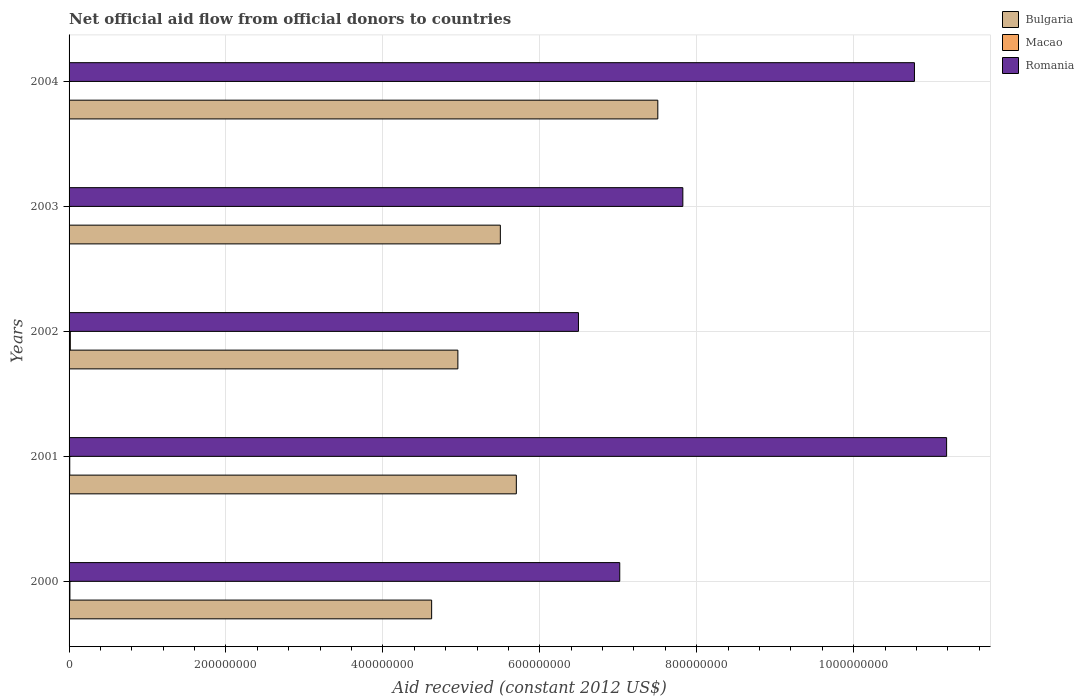How many different coloured bars are there?
Keep it short and to the point. 3. Are the number of bars per tick equal to the number of legend labels?
Keep it short and to the point. Yes. How many bars are there on the 4th tick from the top?
Offer a very short reply. 3. How many bars are there on the 3rd tick from the bottom?
Ensure brevity in your answer.  3. What is the label of the 3rd group of bars from the top?
Your answer should be very brief. 2002. What is the total aid received in Bulgaria in 2001?
Your answer should be compact. 5.70e+08. Across all years, what is the maximum total aid received in Romania?
Offer a terse response. 1.12e+09. Across all years, what is the minimum total aid received in Macao?
Provide a short and direct response. 1.50e+05. In which year was the total aid received in Romania maximum?
Your answer should be very brief. 2001. In which year was the total aid received in Romania minimum?
Your answer should be very brief. 2002. What is the total total aid received in Bulgaria in the graph?
Ensure brevity in your answer.  2.83e+09. What is the difference between the total aid received in Bulgaria in 2000 and that in 2004?
Give a very brief answer. -2.88e+08. What is the difference between the total aid received in Macao in 2003 and the total aid received in Romania in 2002?
Your answer should be compact. -6.49e+08. What is the average total aid received in Romania per year?
Your response must be concise. 8.66e+08. In the year 2002, what is the difference between the total aid received in Romania and total aid received in Macao?
Your response must be concise. 6.48e+08. In how many years, is the total aid received in Romania greater than 1040000000 US$?
Your answer should be very brief. 2. What is the ratio of the total aid received in Romania in 2002 to that in 2004?
Offer a very short reply. 0.6. What is the difference between the highest and the lowest total aid received in Macao?
Your answer should be compact. 1.43e+06. In how many years, is the total aid received in Macao greater than the average total aid received in Macao taken over all years?
Keep it short and to the point. 3. What does the 2nd bar from the top in 2003 represents?
Your answer should be compact. Macao. What does the 3rd bar from the bottom in 2004 represents?
Your response must be concise. Romania. Is it the case that in every year, the sum of the total aid received in Romania and total aid received in Bulgaria is greater than the total aid received in Macao?
Keep it short and to the point. Yes. Does the graph contain grids?
Your answer should be compact. Yes. How are the legend labels stacked?
Your answer should be compact. Vertical. What is the title of the graph?
Your answer should be very brief. Net official aid flow from official donors to countries. Does "Kenya" appear as one of the legend labels in the graph?
Provide a short and direct response. No. What is the label or title of the X-axis?
Your answer should be very brief. Aid recevied (constant 2012 US$). What is the Aid recevied (constant 2012 US$) of Bulgaria in 2000?
Make the answer very short. 4.62e+08. What is the Aid recevied (constant 2012 US$) of Macao in 2000?
Offer a terse response. 1.08e+06. What is the Aid recevied (constant 2012 US$) of Romania in 2000?
Make the answer very short. 7.02e+08. What is the Aid recevied (constant 2012 US$) in Bulgaria in 2001?
Keep it short and to the point. 5.70e+08. What is the Aid recevied (constant 2012 US$) of Macao in 2001?
Make the answer very short. 8.60e+05. What is the Aid recevied (constant 2012 US$) in Romania in 2001?
Offer a very short reply. 1.12e+09. What is the Aid recevied (constant 2012 US$) of Bulgaria in 2002?
Offer a terse response. 4.96e+08. What is the Aid recevied (constant 2012 US$) in Macao in 2002?
Your answer should be compact. 1.58e+06. What is the Aid recevied (constant 2012 US$) of Romania in 2002?
Offer a very short reply. 6.49e+08. What is the Aid recevied (constant 2012 US$) of Bulgaria in 2003?
Make the answer very short. 5.50e+08. What is the Aid recevied (constant 2012 US$) of Romania in 2003?
Keep it short and to the point. 7.82e+08. What is the Aid recevied (constant 2012 US$) of Bulgaria in 2004?
Your answer should be very brief. 7.50e+08. What is the Aid recevied (constant 2012 US$) in Macao in 2004?
Provide a short and direct response. 1.50e+05. What is the Aid recevied (constant 2012 US$) of Romania in 2004?
Keep it short and to the point. 1.08e+09. Across all years, what is the maximum Aid recevied (constant 2012 US$) of Bulgaria?
Offer a terse response. 7.50e+08. Across all years, what is the maximum Aid recevied (constant 2012 US$) in Macao?
Provide a succinct answer. 1.58e+06. Across all years, what is the maximum Aid recevied (constant 2012 US$) in Romania?
Keep it short and to the point. 1.12e+09. Across all years, what is the minimum Aid recevied (constant 2012 US$) of Bulgaria?
Give a very brief answer. 4.62e+08. Across all years, what is the minimum Aid recevied (constant 2012 US$) of Romania?
Provide a succinct answer. 6.49e+08. What is the total Aid recevied (constant 2012 US$) in Bulgaria in the graph?
Give a very brief answer. 2.83e+09. What is the total Aid recevied (constant 2012 US$) in Macao in the graph?
Your answer should be compact. 3.85e+06. What is the total Aid recevied (constant 2012 US$) of Romania in the graph?
Your answer should be very brief. 4.33e+09. What is the difference between the Aid recevied (constant 2012 US$) of Bulgaria in 2000 and that in 2001?
Your answer should be compact. -1.08e+08. What is the difference between the Aid recevied (constant 2012 US$) in Romania in 2000 and that in 2001?
Your answer should be compact. -4.17e+08. What is the difference between the Aid recevied (constant 2012 US$) in Bulgaria in 2000 and that in 2002?
Provide a short and direct response. -3.34e+07. What is the difference between the Aid recevied (constant 2012 US$) in Macao in 2000 and that in 2002?
Offer a terse response. -5.00e+05. What is the difference between the Aid recevied (constant 2012 US$) of Romania in 2000 and that in 2002?
Make the answer very short. 5.26e+07. What is the difference between the Aid recevied (constant 2012 US$) in Bulgaria in 2000 and that in 2003?
Keep it short and to the point. -8.76e+07. What is the difference between the Aid recevied (constant 2012 US$) in Macao in 2000 and that in 2003?
Offer a very short reply. 9.00e+05. What is the difference between the Aid recevied (constant 2012 US$) in Romania in 2000 and that in 2003?
Give a very brief answer. -8.04e+07. What is the difference between the Aid recevied (constant 2012 US$) in Bulgaria in 2000 and that in 2004?
Give a very brief answer. -2.88e+08. What is the difference between the Aid recevied (constant 2012 US$) in Macao in 2000 and that in 2004?
Your response must be concise. 9.30e+05. What is the difference between the Aid recevied (constant 2012 US$) of Romania in 2000 and that in 2004?
Provide a short and direct response. -3.76e+08. What is the difference between the Aid recevied (constant 2012 US$) of Bulgaria in 2001 and that in 2002?
Ensure brevity in your answer.  7.45e+07. What is the difference between the Aid recevied (constant 2012 US$) in Macao in 2001 and that in 2002?
Provide a succinct answer. -7.20e+05. What is the difference between the Aid recevied (constant 2012 US$) of Romania in 2001 and that in 2002?
Offer a terse response. 4.69e+08. What is the difference between the Aid recevied (constant 2012 US$) in Bulgaria in 2001 and that in 2003?
Offer a very short reply. 2.04e+07. What is the difference between the Aid recevied (constant 2012 US$) in Macao in 2001 and that in 2003?
Offer a terse response. 6.80e+05. What is the difference between the Aid recevied (constant 2012 US$) of Romania in 2001 and that in 2003?
Keep it short and to the point. 3.36e+08. What is the difference between the Aid recevied (constant 2012 US$) in Bulgaria in 2001 and that in 2004?
Offer a terse response. -1.80e+08. What is the difference between the Aid recevied (constant 2012 US$) in Macao in 2001 and that in 2004?
Provide a succinct answer. 7.10e+05. What is the difference between the Aid recevied (constant 2012 US$) of Romania in 2001 and that in 2004?
Provide a succinct answer. 4.10e+07. What is the difference between the Aid recevied (constant 2012 US$) of Bulgaria in 2002 and that in 2003?
Keep it short and to the point. -5.41e+07. What is the difference between the Aid recevied (constant 2012 US$) of Macao in 2002 and that in 2003?
Offer a very short reply. 1.40e+06. What is the difference between the Aid recevied (constant 2012 US$) of Romania in 2002 and that in 2003?
Provide a succinct answer. -1.33e+08. What is the difference between the Aid recevied (constant 2012 US$) in Bulgaria in 2002 and that in 2004?
Give a very brief answer. -2.55e+08. What is the difference between the Aid recevied (constant 2012 US$) in Macao in 2002 and that in 2004?
Provide a short and direct response. 1.43e+06. What is the difference between the Aid recevied (constant 2012 US$) in Romania in 2002 and that in 2004?
Make the answer very short. -4.28e+08. What is the difference between the Aid recevied (constant 2012 US$) in Bulgaria in 2003 and that in 2004?
Provide a short and direct response. -2.01e+08. What is the difference between the Aid recevied (constant 2012 US$) in Macao in 2003 and that in 2004?
Provide a short and direct response. 3.00e+04. What is the difference between the Aid recevied (constant 2012 US$) in Romania in 2003 and that in 2004?
Ensure brevity in your answer.  -2.95e+08. What is the difference between the Aid recevied (constant 2012 US$) in Bulgaria in 2000 and the Aid recevied (constant 2012 US$) in Macao in 2001?
Ensure brevity in your answer.  4.61e+08. What is the difference between the Aid recevied (constant 2012 US$) of Bulgaria in 2000 and the Aid recevied (constant 2012 US$) of Romania in 2001?
Give a very brief answer. -6.56e+08. What is the difference between the Aid recevied (constant 2012 US$) of Macao in 2000 and the Aid recevied (constant 2012 US$) of Romania in 2001?
Your answer should be very brief. -1.12e+09. What is the difference between the Aid recevied (constant 2012 US$) in Bulgaria in 2000 and the Aid recevied (constant 2012 US$) in Macao in 2002?
Provide a succinct answer. 4.61e+08. What is the difference between the Aid recevied (constant 2012 US$) in Bulgaria in 2000 and the Aid recevied (constant 2012 US$) in Romania in 2002?
Keep it short and to the point. -1.87e+08. What is the difference between the Aid recevied (constant 2012 US$) in Macao in 2000 and the Aid recevied (constant 2012 US$) in Romania in 2002?
Your response must be concise. -6.48e+08. What is the difference between the Aid recevied (constant 2012 US$) in Bulgaria in 2000 and the Aid recevied (constant 2012 US$) in Macao in 2003?
Offer a very short reply. 4.62e+08. What is the difference between the Aid recevied (constant 2012 US$) in Bulgaria in 2000 and the Aid recevied (constant 2012 US$) in Romania in 2003?
Your response must be concise. -3.20e+08. What is the difference between the Aid recevied (constant 2012 US$) in Macao in 2000 and the Aid recevied (constant 2012 US$) in Romania in 2003?
Provide a succinct answer. -7.81e+08. What is the difference between the Aid recevied (constant 2012 US$) of Bulgaria in 2000 and the Aid recevied (constant 2012 US$) of Macao in 2004?
Your answer should be very brief. 4.62e+08. What is the difference between the Aid recevied (constant 2012 US$) of Bulgaria in 2000 and the Aid recevied (constant 2012 US$) of Romania in 2004?
Offer a terse response. -6.15e+08. What is the difference between the Aid recevied (constant 2012 US$) of Macao in 2000 and the Aid recevied (constant 2012 US$) of Romania in 2004?
Your answer should be compact. -1.08e+09. What is the difference between the Aid recevied (constant 2012 US$) in Bulgaria in 2001 and the Aid recevied (constant 2012 US$) in Macao in 2002?
Ensure brevity in your answer.  5.68e+08. What is the difference between the Aid recevied (constant 2012 US$) in Bulgaria in 2001 and the Aid recevied (constant 2012 US$) in Romania in 2002?
Ensure brevity in your answer.  -7.92e+07. What is the difference between the Aid recevied (constant 2012 US$) of Macao in 2001 and the Aid recevied (constant 2012 US$) of Romania in 2002?
Give a very brief answer. -6.48e+08. What is the difference between the Aid recevied (constant 2012 US$) in Bulgaria in 2001 and the Aid recevied (constant 2012 US$) in Macao in 2003?
Offer a terse response. 5.70e+08. What is the difference between the Aid recevied (constant 2012 US$) in Bulgaria in 2001 and the Aid recevied (constant 2012 US$) in Romania in 2003?
Provide a succinct answer. -2.12e+08. What is the difference between the Aid recevied (constant 2012 US$) of Macao in 2001 and the Aid recevied (constant 2012 US$) of Romania in 2003?
Keep it short and to the point. -7.81e+08. What is the difference between the Aid recevied (constant 2012 US$) in Bulgaria in 2001 and the Aid recevied (constant 2012 US$) in Macao in 2004?
Provide a short and direct response. 5.70e+08. What is the difference between the Aid recevied (constant 2012 US$) of Bulgaria in 2001 and the Aid recevied (constant 2012 US$) of Romania in 2004?
Offer a terse response. -5.07e+08. What is the difference between the Aid recevied (constant 2012 US$) in Macao in 2001 and the Aid recevied (constant 2012 US$) in Romania in 2004?
Your answer should be compact. -1.08e+09. What is the difference between the Aid recevied (constant 2012 US$) in Bulgaria in 2002 and the Aid recevied (constant 2012 US$) in Macao in 2003?
Offer a very short reply. 4.95e+08. What is the difference between the Aid recevied (constant 2012 US$) of Bulgaria in 2002 and the Aid recevied (constant 2012 US$) of Romania in 2003?
Your response must be concise. -2.87e+08. What is the difference between the Aid recevied (constant 2012 US$) of Macao in 2002 and the Aid recevied (constant 2012 US$) of Romania in 2003?
Your answer should be compact. -7.81e+08. What is the difference between the Aid recevied (constant 2012 US$) in Bulgaria in 2002 and the Aid recevied (constant 2012 US$) in Macao in 2004?
Your answer should be very brief. 4.95e+08. What is the difference between the Aid recevied (constant 2012 US$) in Bulgaria in 2002 and the Aid recevied (constant 2012 US$) in Romania in 2004?
Keep it short and to the point. -5.82e+08. What is the difference between the Aid recevied (constant 2012 US$) in Macao in 2002 and the Aid recevied (constant 2012 US$) in Romania in 2004?
Your answer should be very brief. -1.08e+09. What is the difference between the Aid recevied (constant 2012 US$) in Bulgaria in 2003 and the Aid recevied (constant 2012 US$) in Macao in 2004?
Ensure brevity in your answer.  5.50e+08. What is the difference between the Aid recevied (constant 2012 US$) in Bulgaria in 2003 and the Aid recevied (constant 2012 US$) in Romania in 2004?
Provide a succinct answer. -5.28e+08. What is the difference between the Aid recevied (constant 2012 US$) in Macao in 2003 and the Aid recevied (constant 2012 US$) in Romania in 2004?
Your response must be concise. -1.08e+09. What is the average Aid recevied (constant 2012 US$) in Bulgaria per year?
Provide a short and direct response. 5.66e+08. What is the average Aid recevied (constant 2012 US$) of Macao per year?
Your answer should be compact. 7.70e+05. What is the average Aid recevied (constant 2012 US$) in Romania per year?
Offer a very short reply. 8.66e+08. In the year 2000, what is the difference between the Aid recevied (constant 2012 US$) in Bulgaria and Aid recevied (constant 2012 US$) in Macao?
Your answer should be compact. 4.61e+08. In the year 2000, what is the difference between the Aid recevied (constant 2012 US$) in Bulgaria and Aid recevied (constant 2012 US$) in Romania?
Make the answer very short. -2.40e+08. In the year 2000, what is the difference between the Aid recevied (constant 2012 US$) of Macao and Aid recevied (constant 2012 US$) of Romania?
Your answer should be compact. -7.01e+08. In the year 2001, what is the difference between the Aid recevied (constant 2012 US$) in Bulgaria and Aid recevied (constant 2012 US$) in Macao?
Your answer should be very brief. 5.69e+08. In the year 2001, what is the difference between the Aid recevied (constant 2012 US$) in Bulgaria and Aid recevied (constant 2012 US$) in Romania?
Make the answer very short. -5.48e+08. In the year 2001, what is the difference between the Aid recevied (constant 2012 US$) of Macao and Aid recevied (constant 2012 US$) of Romania?
Offer a very short reply. -1.12e+09. In the year 2002, what is the difference between the Aid recevied (constant 2012 US$) in Bulgaria and Aid recevied (constant 2012 US$) in Macao?
Provide a short and direct response. 4.94e+08. In the year 2002, what is the difference between the Aid recevied (constant 2012 US$) in Bulgaria and Aid recevied (constant 2012 US$) in Romania?
Offer a terse response. -1.54e+08. In the year 2002, what is the difference between the Aid recevied (constant 2012 US$) in Macao and Aid recevied (constant 2012 US$) in Romania?
Give a very brief answer. -6.48e+08. In the year 2003, what is the difference between the Aid recevied (constant 2012 US$) of Bulgaria and Aid recevied (constant 2012 US$) of Macao?
Provide a short and direct response. 5.49e+08. In the year 2003, what is the difference between the Aid recevied (constant 2012 US$) of Bulgaria and Aid recevied (constant 2012 US$) of Romania?
Provide a succinct answer. -2.33e+08. In the year 2003, what is the difference between the Aid recevied (constant 2012 US$) in Macao and Aid recevied (constant 2012 US$) in Romania?
Keep it short and to the point. -7.82e+08. In the year 2004, what is the difference between the Aid recevied (constant 2012 US$) of Bulgaria and Aid recevied (constant 2012 US$) of Macao?
Provide a short and direct response. 7.50e+08. In the year 2004, what is the difference between the Aid recevied (constant 2012 US$) of Bulgaria and Aid recevied (constant 2012 US$) of Romania?
Keep it short and to the point. -3.27e+08. In the year 2004, what is the difference between the Aid recevied (constant 2012 US$) of Macao and Aid recevied (constant 2012 US$) of Romania?
Offer a terse response. -1.08e+09. What is the ratio of the Aid recevied (constant 2012 US$) of Bulgaria in 2000 to that in 2001?
Your answer should be very brief. 0.81. What is the ratio of the Aid recevied (constant 2012 US$) in Macao in 2000 to that in 2001?
Your response must be concise. 1.26. What is the ratio of the Aid recevied (constant 2012 US$) of Romania in 2000 to that in 2001?
Ensure brevity in your answer.  0.63. What is the ratio of the Aid recevied (constant 2012 US$) of Bulgaria in 2000 to that in 2002?
Your response must be concise. 0.93. What is the ratio of the Aid recevied (constant 2012 US$) in Macao in 2000 to that in 2002?
Your answer should be very brief. 0.68. What is the ratio of the Aid recevied (constant 2012 US$) of Romania in 2000 to that in 2002?
Ensure brevity in your answer.  1.08. What is the ratio of the Aid recevied (constant 2012 US$) in Bulgaria in 2000 to that in 2003?
Provide a succinct answer. 0.84. What is the ratio of the Aid recevied (constant 2012 US$) of Romania in 2000 to that in 2003?
Offer a terse response. 0.9. What is the ratio of the Aid recevied (constant 2012 US$) of Bulgaria in 2000 to that in 2004?
Provide a succinct answer. 0.62. What is the ratio of the Aid recevied (constant 2012 US$) of Romania in 2000 to that in 2004?
Make the answer very short. 0.65. What is the ratio of the Aid recevied (constant 2012 US$) of Bulgaria in 2001 to that in 2002?
Offer a very short reply. 1.15. What is the ratio of the Aid recevied (constant 2012 US$) in Macao in 2001 to that in 2002?
Ensure brevity in your answer.  0.54. What is the ratio of the Aid recevied (constant 2012 US$) in Romania in 2001 to that in 2002?
Keep it short and to the point. 1.72. What is the ratio of the Aid recevied (constant 2012 US$) in Bulgaria in 2001 to that in 2003?
Ensure brevity in your answer.  1.04. What is the ratio of the Aid recevied (constant 2012 US$) in Macao in 2001 to that in 2003?
Give a very brief answer. 4.78. What is the ratio of the Aid recevied (constant 2012 US$) of Romania in 2001 to that in 2003?
Ensure brevity in your answer.  1.43. What is the ratio of the Aid recevied (constant 2012 US$) of Bulgaria in 2001 to that in 2004?
Provide a succinct answer. 0.76. What is the ratio of the Aid recevied (constant 2012 US$) of Macao in 2001 to that in 2004?
Provide a succinct answer. 5.73. What is the ratio of the Aid recevied (constant 2012 US$) in Romania in 2001 to that in 2004?
Provide a succinct answer. 1.04. What is the ratio of the Aid recevied (constant 2012 US$) of Bulgaria in 2002 to that in 2003?
Make the answer very short. 0.9. What is the ratio of the Aid recevied (constant 2012 US$) of Macao in 2002 to that in 2003?
Make the answer very short. 8.78. What is the ratio of the Aid recevied (constant 2012 US$) of Romania in 2002 to that in 2003?
Ensure brevity in your answer.  0.83. What is the ratio of the Aid recevied (constant 2012 US$) in Bulgaria in 2002 to that in 2004?
Offer a terse response. 0.66. What is the ratio of the Aid recevied (constant 2012 US$) in Macao in 2002 to that in 2004?
Your answer should be compact. 10.53. What is the ratio of the Aid recevied (constant 2012 US$) in Romania in 2002 to that in 2004?
Keep it short and to the point. 0.6. What is the ratio of the Aid recevied (constant 2012 US$) in Bulgaria in 2003 to that in 2004?
Make the answer very short. 0.73. What is the ratio of the Aid recevied (constant 2012 US$) in Romania in 2003 to that in 2004?
Provide a succinct answer. 0.73. What is the difference between the highest and the second highest Aid recevied (constant 2012 US$) in Bulgaria?
Offer a very short reply. 1.80e+08. What is the difference between the highest and the second highest Aid recevied (constant 2012 US$) of Romania?
Your answer should be compact. 4.10e+07. What is the difference between the highest and the lowest Aid recevied (constant 2012 US$) in Bulgaria?
Provide a short and direct response. 2.88e+08. What is the difference between the highest and the lowest Aid recevied (constant 2012 US$) of Macao?
Give a very brief answer. 1.43e+06. What is the difference between the highest and the lowest Aid recevied (constant 2012 US$) of Romania?
Your response must be concise. 4.69e+08. 